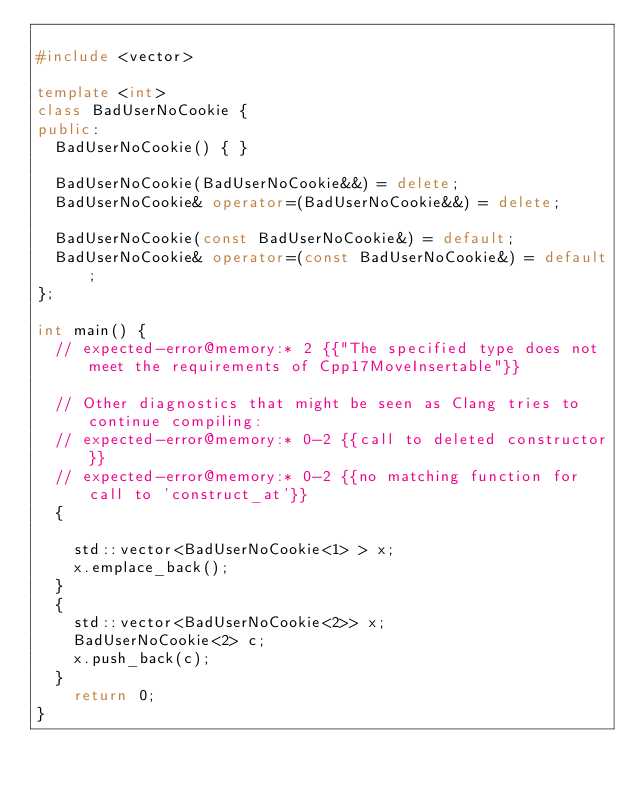Convert code to text. <code><loc_0><loc_0><loc_500><loc_500><_C++_>
#include <vector>

template <int>
class BadUserNoCookie {
public:
  BadUserNoCookie() { }

  BadUserNoCookie(BadUserNoCookie&&) = delete;
  BadUserNoCookie& operator=(BadUserNoCookie&&) = delete;

  BadUserNoCookie(const BadUserNoCookie&) = default;
  BadUserNoCookie& operator=(const BadUserNoCookie&) = default;
};

int main() {
  // expected-error@memory:* 2 {{"The specified type does not meet the requirements of Cpp17MoveInsertable"}}

  // Other diagnostics that might be seen as Clang tries to continue compiling:
  // expected-error@memory:* 0-2 {{call to deleted constructor}}
  // expected-error@memory:* 0-2 {{no matching function for call to 'construct_at'}}
  {

    std::vector<BadUserNoCookie<1> > x;
    x.emplace_back();
  }
  {
    std::vector<BadUserNoCookie<2>> x;
    BadUserNoCookie<2> c;
    x.push_back(c);
  }
    return 0;
}
</code> 